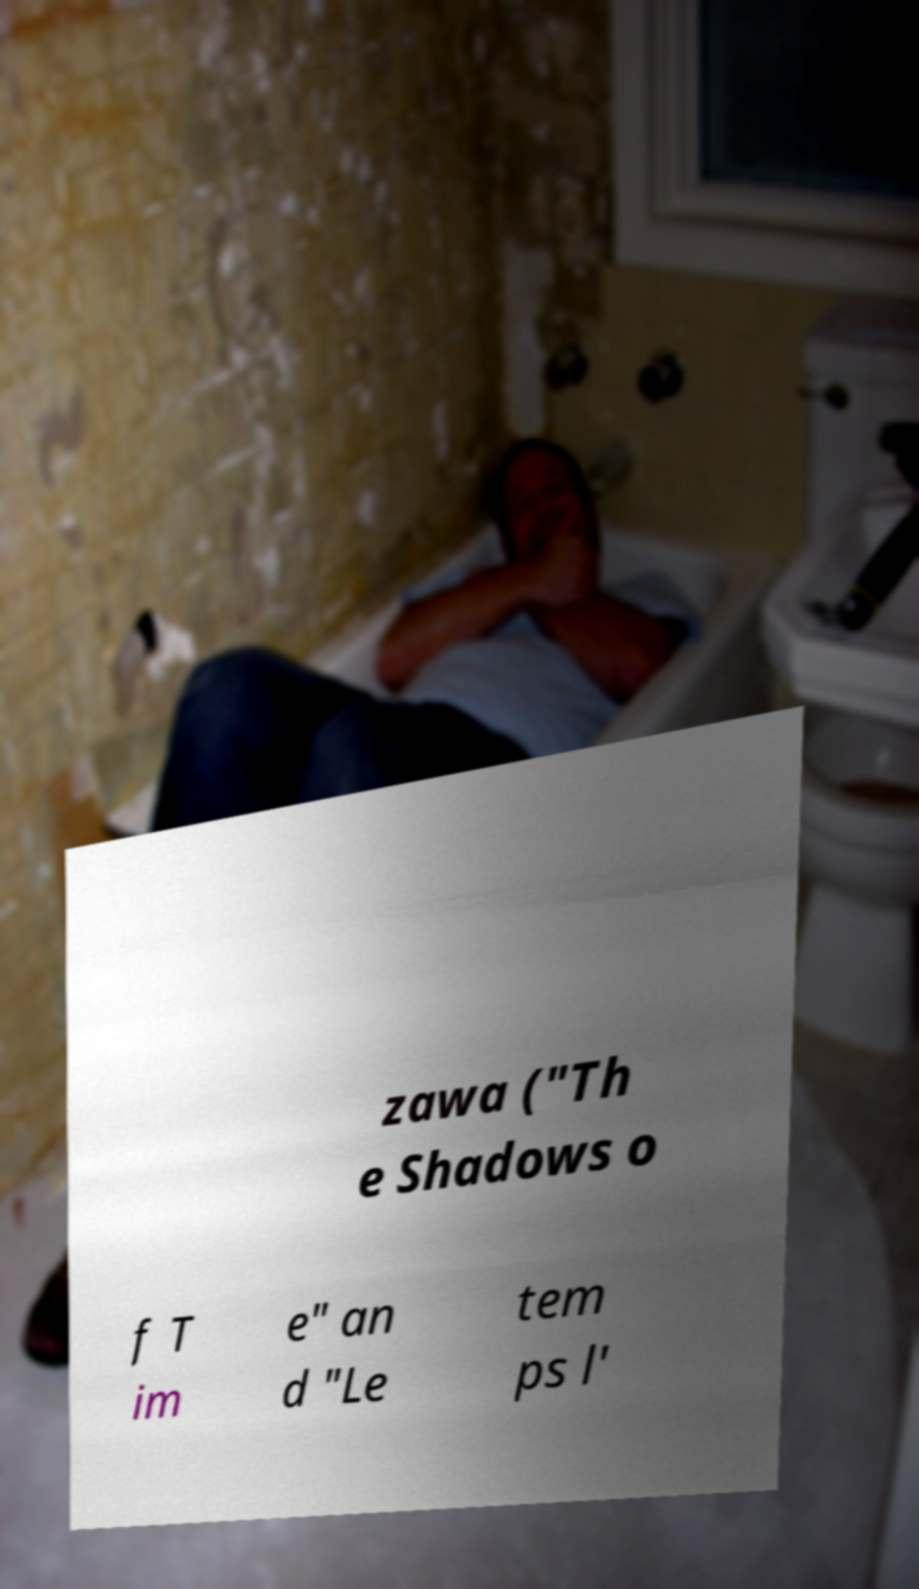Please read and relay the text visible in this image. What does it say? zawa ("Th e Shadows o f T im e" an d "Le tem ps l' 